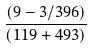<formula> <loc_0><loc_0><loc_500><loc_500>\frac { ( 9 - 3 / 3 9 6 ) } { ( 1 1 9 + 4 9 3 ) }</formula> 